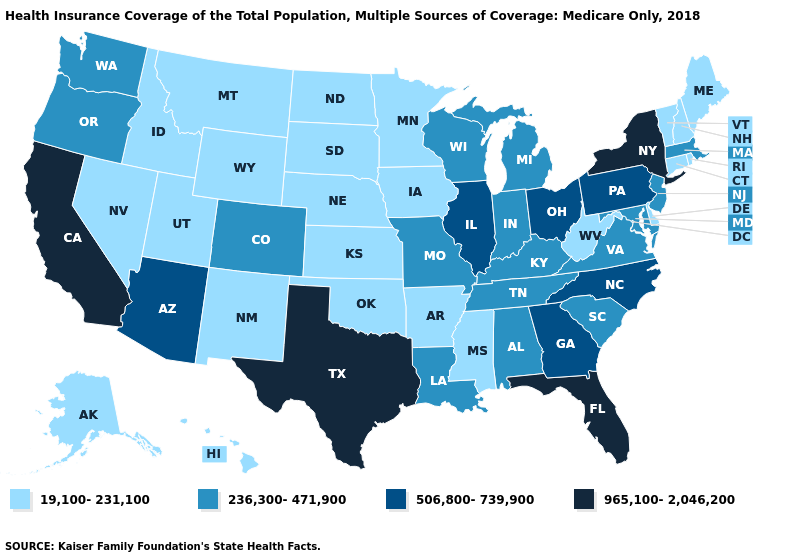Which states hav the highest value in the MidWest?
Be succinct. Illinois, Ohio. What is the highest value in the USA?
Be succinct. 965,100-2,046,200. What is the value of Colorado?
Write a very short answer. 236,300-471,900. Name the states that have a value in the range 236,300-471,900?
Quick response, please. Alabama, Colorado, Indiana, Kentucky, Louisiana, Maryland, Massachusetts, Michigan, Missouri, New Jersey, Oregon, South Carolina, Tennessee, Virginia, Washington, Wisconsin. Name the states that have a value in the range 236,300-471,900?
Concise answer only. Alabama, Colorado, Indiana, Kentucky, Louisiana, Maryland, Massachusetts, Michigan, Missouri, New Jersey, Oregon, South Carolina, Tennessee, Virginia, Washington, Wisconsin. Name the states that have a value in the range 19,100-231,100?
Keep it brief. Alaska, Arkansas, Connecticut, Delaware, Hawaii, Idaho, Iowa, Kansas, Maine, Minnesota, Mississippi, Montana, Nebraska, Nevada, New Hampshire, New Mexico, North Dakota, Oklahoma, Rhode Island, South Dakota, Utah, Vermont, West Virginia, Wyoming. Among the states that border Tennessee , which have the highest value?
Answer briefly. Georgia, North Carolina. What is the highest value in the MidWest ?
Give a very brief answer. 506,800-739,900. What is the value of Maine?
Write a very short answer. 19,100-231,100. What is the value of Idaho?
Keep it brief. 19,100-231,100. What is the lowest value in the West?
Write a very short answer. 19,100-231,100. What is the value of South Dakota?
Write a very short answer. 19,100-231,100. Name the states that have a value in the range 236,300-471,900?
Short answer required. Alabama, Colorado, Indiana, Kentucky, Louisiana, Maryland, Massachusetts, Michigan, Missouri, New Jersey, Oregon, South Carolina, Tennessee, Virginia, Washington, Wisconsin. Name the states that have a value in the range 19,100-231,100?
Write a very short answer. Alaska, Arkansas, Connecticut, Delaware, Hawaii, Idaho, Iowa, Kansas, Maine, Minnesota, Mississippi, Montana, Nebraska, Nevada, New Hampshire, New Mexico, North Dakota, Oklahoma, Rhode Island, South Dakota, Utah, Vermont, West Virginia, Wyoming. Name the states that have a value in the range 506,800-739,900?
Keep it brief. Arizona, Georgia, Illinois, North Carolina, Ohio, Pennsylvania. 